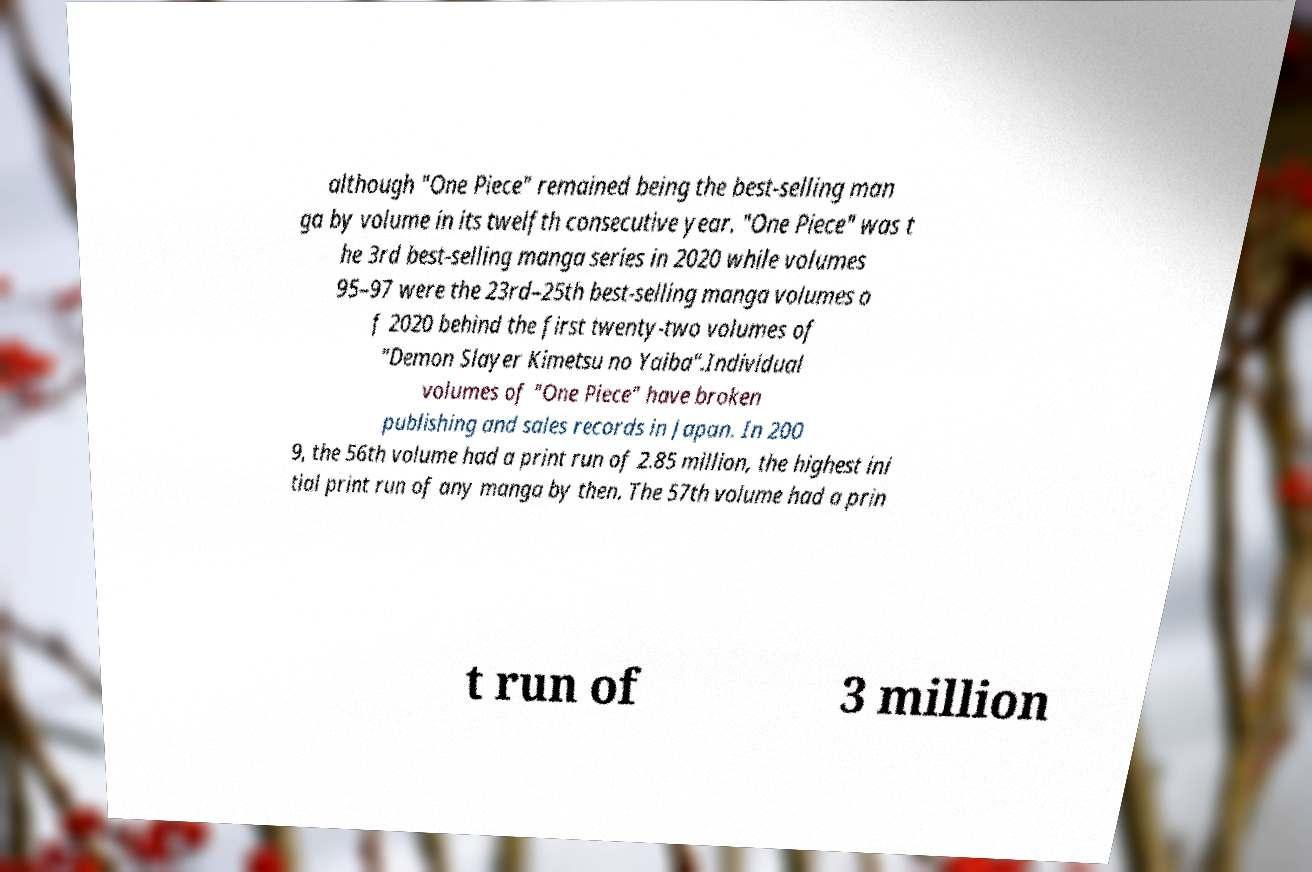Could you extract and type out the text from this image? although "One Piece" remained being the best-selling man ga by volume in its twelfth consecutive year. "One Piece" was t he 3rd best-selling manga series in 2020 while volumes 95–97 were the 23rd–25th best-selling manga volumes o f 2020 behind the first twenty-two volumes of "Demon Slayer Kimetsu no Yaiba".Individual volumes of "One Piece" have broken publishing and sales records in Japan. In 200 9, the 56th volume had a print run of 2.85 million, the highest ini tial print run of any manga by then. The 57th volume had a prin t run of 3 million 